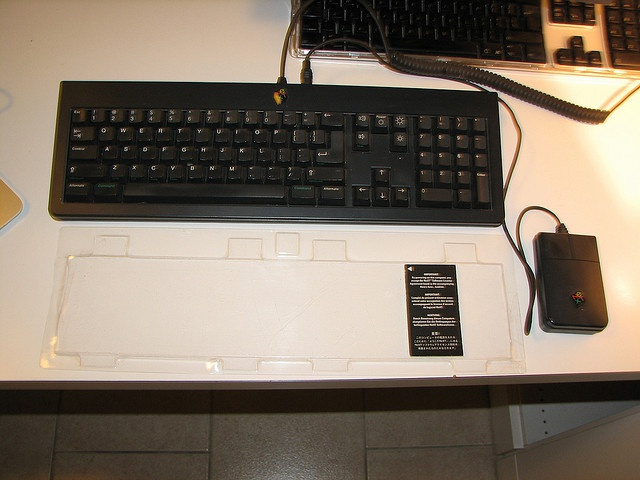Describe the objects in this image and their specific colors. I can see keyboard in gray, black, and darkgray tones, keyboard in gray, black, maroon, and tan tones, and mouse in gray, black, and maroon tones in this image. 